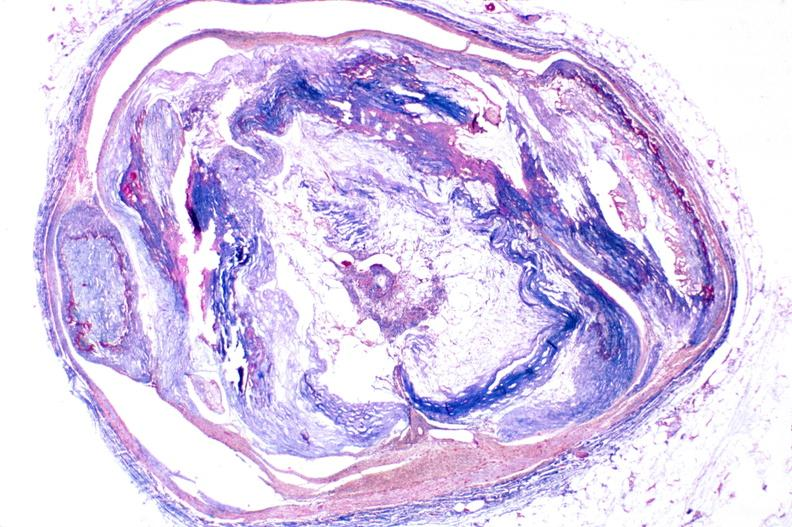s stillborn cord around neck present?
Answer the question using a single word or phrase. No 